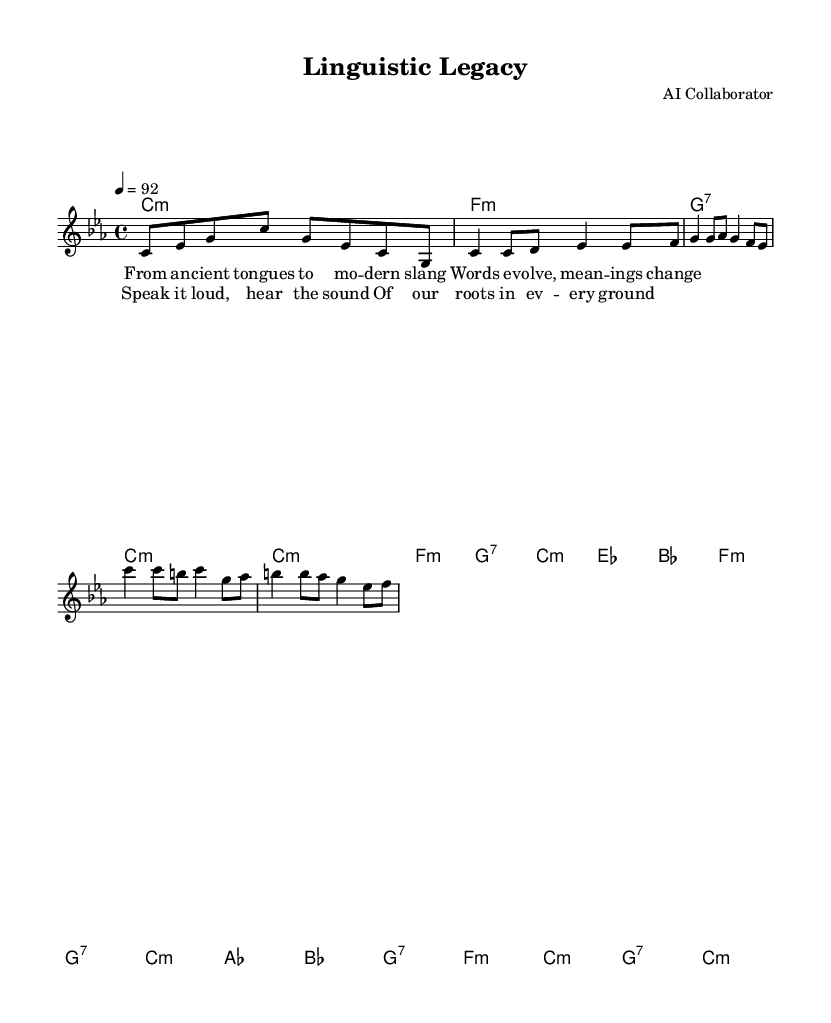What is the key signature of this music? The key signature can be found at the beginning of the staff notes. It indicates C minor, which has three flats.
Answer: C minor What is the time signature of this music? The time signature is indicated at the beginning of the score, specifying how many beats are in each measure. This score shows a 4/4 time signature.
Answer: 4/4 What is the tempo marking for this piece? The tempo marking is indicated in beats per minute (BPM) and is found at the start of the score. This piece has a tempo of 92.
Answer: 92 How many measures are in the verse? The verse contains a set number of measures, which can be counted in the scored section labeled as "Verse." In this case, there are 8 measures in the verse.
Answer: 8 What is the emotional tone of the chorus based on the lyrics? The emotional tone can be inferred from the lyrics in the chorus, which expresses pride in cultural roots and a sense of unity. The use of "Speak it loud" conveys a positive and uplifting tone.
Answer: Uplifting Which musical element is repeated in both the verse and chorus? A musical element that is often repeated in structure is the melody, specifically the rhythm and flow of the lyrics, which provide cohesion between the verse and chorus. In this case, there are rhythmic similarities that connect the two sections.
Answer: Rhythm What genre does this piece of music represent? The overall style and lyrical content reflect the genre, specifically the incorporation of social themes and contemporary language, which are characteristic of rap music.
Answer: Rap 